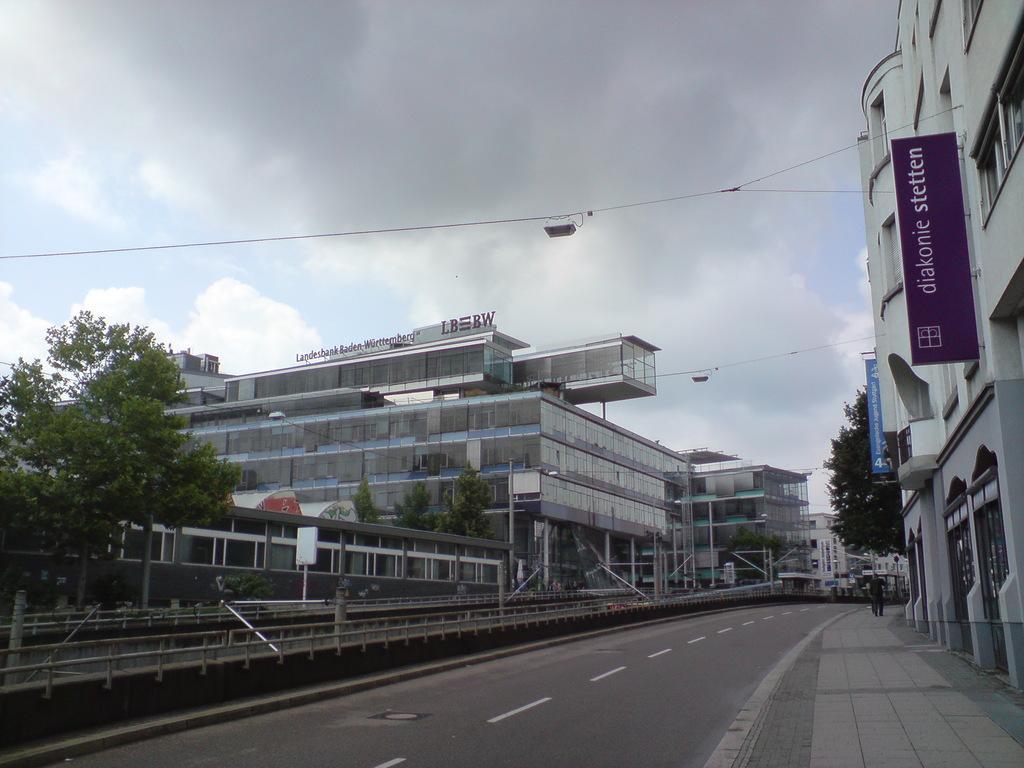Describe this image in one or two sentences. In this image there is sky, there are bulidingś, there are is a tree, there is a road, there are wires, there is a board. 